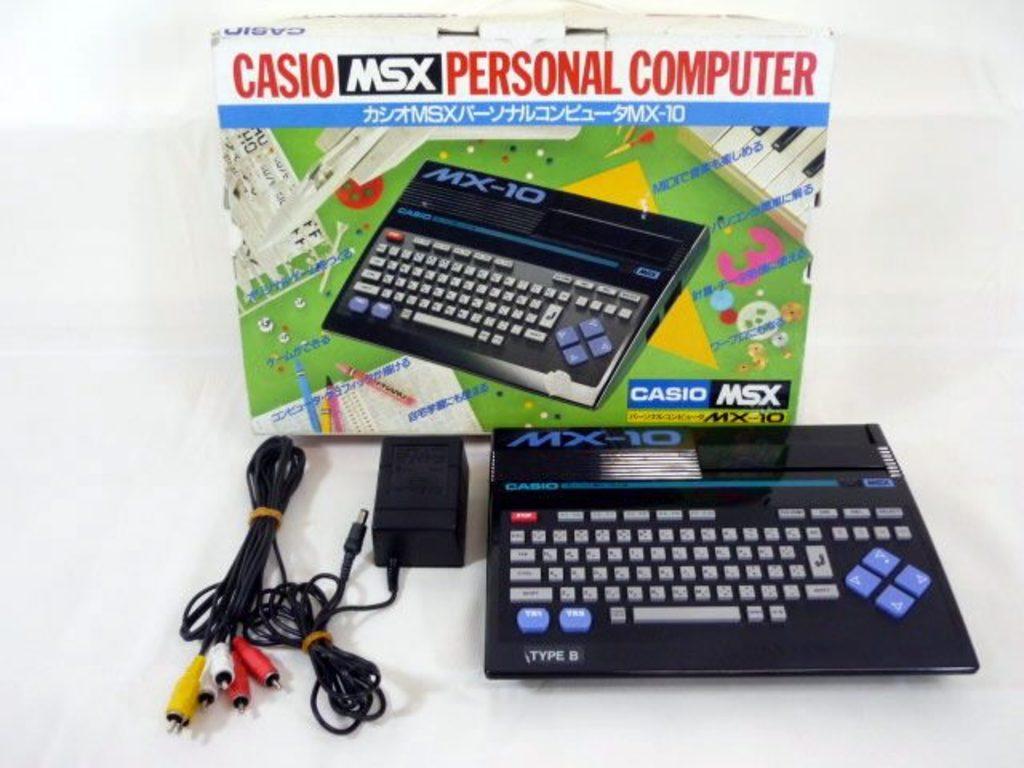What model number is this personal computer?
Provide a succinct answer. Mx-10. What brand is this electronic device?
Ensure brevity in your answer.  Casio. 